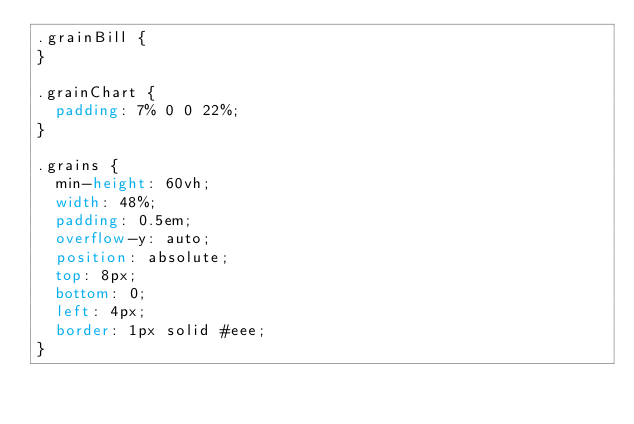<code> <loc_0><loc_0><loc_500><loc_500><_CSS_>.grainBill {
}

.grainChart {
  padding: 7% 0 0 22%;
}

.grains {
  min-height: 60vh;
  width: 48%;
  padding: 0.5em;
  overflow-y: auto;
  position: absolute;
  top: 8px;
  bottom: 0;
  left: 4px;
  border: 1px solid #eee;
}
</code> 